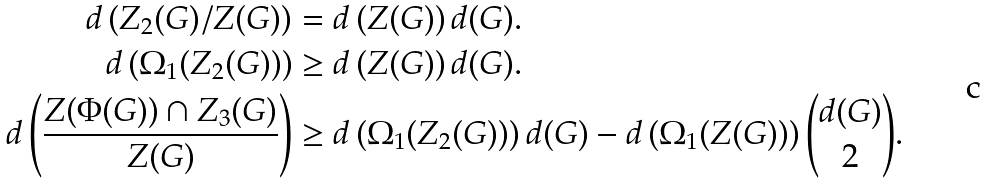<formula> <loc_0><loc_0><loc_500><loc_500>d \left ( Z _ { 2 } ( G ) / Z ( G ) \right ) & = d \left ( Z ( G ) \right ) d ( G ) . \\ d \left ( \Omega _ { 1 } ( Z _ { 2 } ( G ) ) \right ) & \geq d \left ( Z ( G ) \right ) d ( G ) . \\ d \left ( \frac { Z ( \Phi ( G ) ) \cap Z _ { 3 } ( G ) } { Z ( G ) } \right ) & \geq d \left ( \Omega _ { 1 } ( Z _ { 2 } ( G ) ) \right ) d ( G ) - d \left ( \Omega _ { 1 } ( Z ( G ) ) \right ) { { d ( G ) } \choose { 2 } } .</formula> 